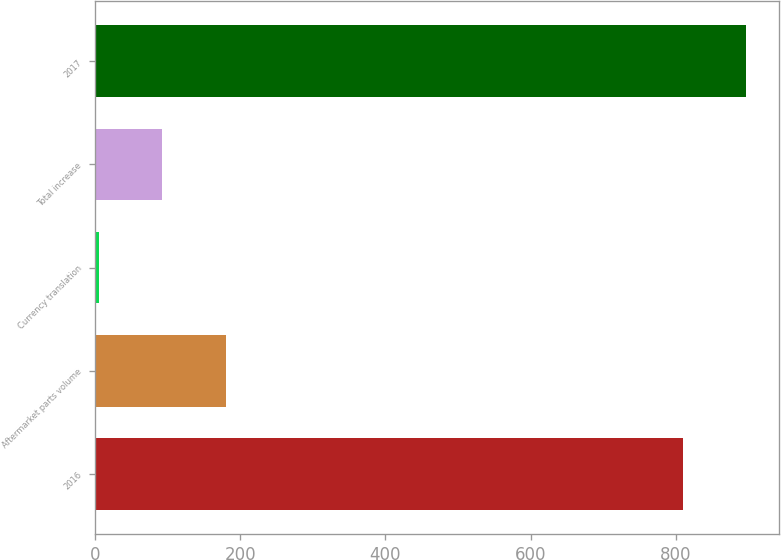Convert chart to OTSL. <chart><loc_0><loc_0><loc_500><loc_500><bar_chart><fcel>2016<fcel>Aftermarket parts volume<fcel>Currency translation<fcel>Total increase<fcel>2017<nl><fcel>809.3<fcel>180.16<fcel>4.9<fcel>92.53<fcel>896.93<nl></chart> 